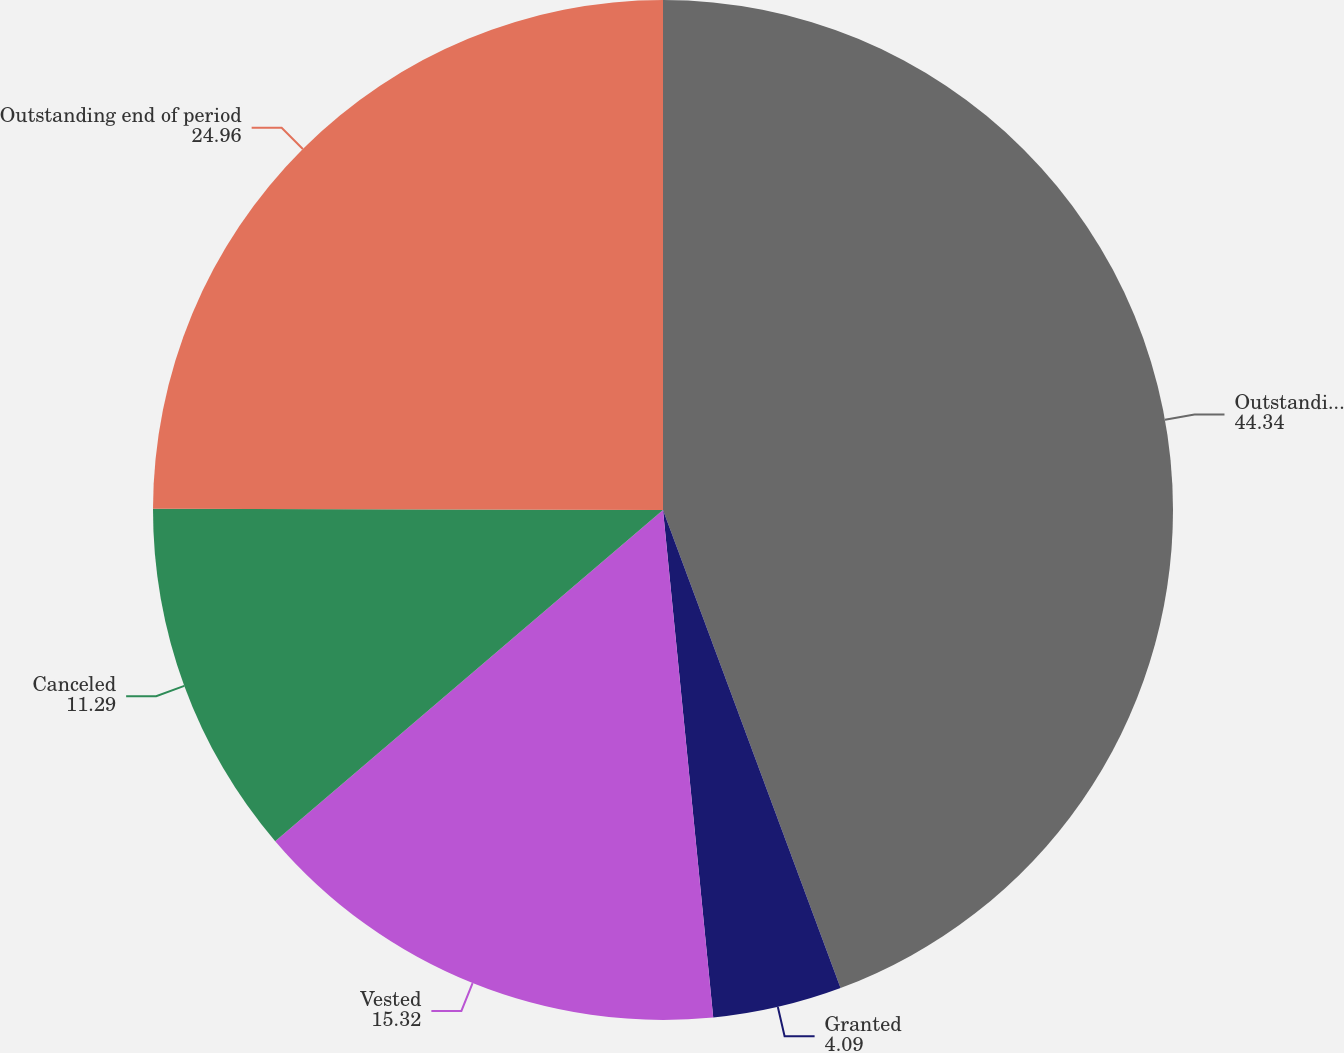Convert chart to OTSL. <chart><loc_0><loc_0><loc_500><loc_500><pie_chart><fcel>Outstanding beginning of<fcel>Granted<fcel>Vested<fcel>Canceled<fcel>Outstanding end of period<nl><fcel>44.34%<fcel>4.09%<fcel>15.32%<fcel>11.29%<fcel>24.96%<nl></chart> 